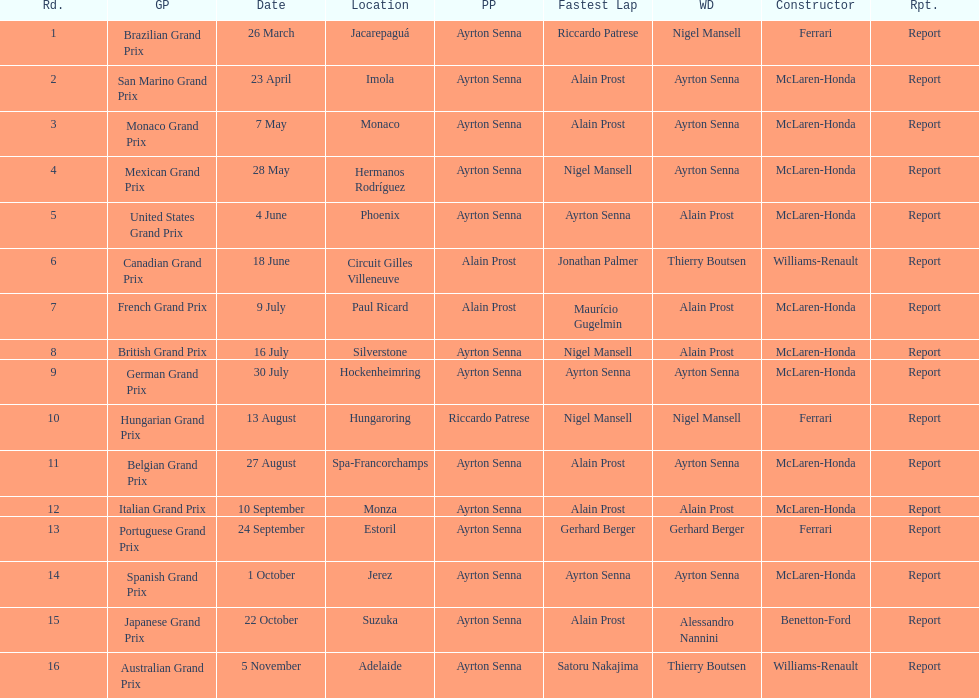How many times was ayrton senna in pole position? 13. 